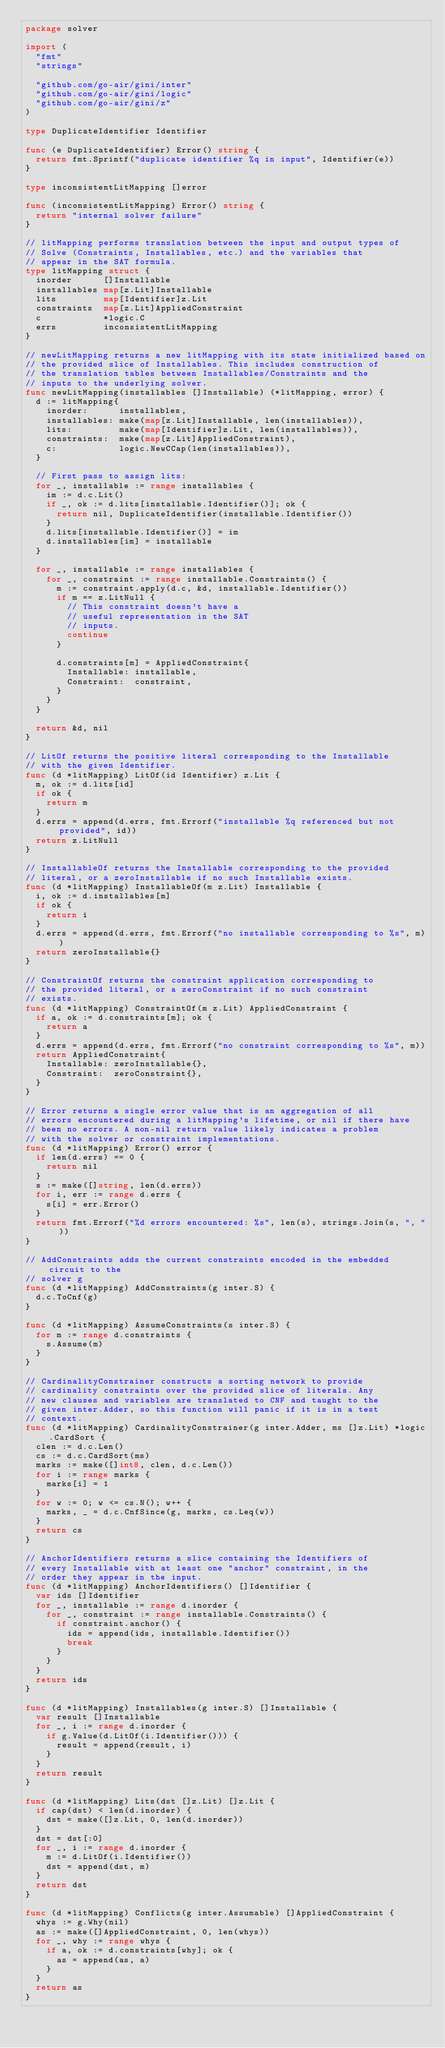<code> <loc_0><loc_0><loc_500><loc_500><_Go_>package solver

import (
	"fmt"
	"strings"

	"github.com/go-air/gini/inter"
	"github.com/go-air/gini/logic"
	"github.com/go-air/gini/z"
)

type DuplicateIdentifier Identifier

func (e DuplicateIdentifier) Error() string {
	return fmt.Sprintf("duplicate identifier %q in input", Identifier(e))
}

type inconsistentLitMapping []error

func (inconsistentLitMapping) Error() string {
	return "internal solver failure"
}

// litMapping performs translation between the input and output types of
// Solve (Constraints, Installables, etc.) and the variables that
// appear in the SAT formula.
type litMapping struct {
	inorder      []Installable
	installables map[z.Lit]Installable
	lits         map[Identifier]z.Lit
	constraints  map[z.Lit]AppliedConstraint
	c            *logic.C
	errs         inconsistentLitMapping
}

// newLitMapping returns a new litMapping with its state initialized based on
// the provided slice of Installables. This includes construction of
// the translation tables between Installables/Constraints and the
// inputs to the underlying solver.
func newLitMapping(installables []Installable) (*litMapping, error) {
	d := litMapping{
		inorder:      installables,
		installables: make(map[z.Lit]Installable, len(installables)),
		lits:         make(map[Identifier]z.Lit, len(installables)),
		constraints:  make(map[z.Lit]AppliedConstraint),
		c:            logic.NewCCap(len(installables)),
	}

	// First pass to assign lits:
	for _, installable := range installables {
		im := d.c.Lit()
		if _, ok := d.lits[installable.Identifier()]; ok {
			return nil, DuplicateIdentifier(installable.Identifier())
		}
		d.lits[installable.Identifier()] = im
		d.installables[im] = installable
	}

	for _, installable := range installables {
		for _, constraint := range installable.Constraints() {
			m := constraint.apply(d.c, &d, installable.Identifier())
			if m == z.LitNull {
				// This constraint doesn't have a
				// useful representation in the SAT
				// inputs.
				continue
			}

			d.constraints[m] = AppliedConstraint{
				Installable: installable,
				Constraint:  constraint,
			}
		}
	}

	return &d, nil
}

// LitOf returns the positive literal corresponding to the Installable
// with the given Identifier.
func (d *litMapping) LitOf(id Identifier) z.Lit {
	m, ok := d.lits[id]
	if ok {
		return m
	}
	d.errs = append(d.errs, fmt.Errorf("installable %q referenced but not provided", id))
	return z.LitNull
}

// InstallableOf returns the Installable corresponding to the provided
// literal, or a zeroInstallable if no such Installable exists.
func (d *litMapping) InstallableOf(m z.Lit) Installable {
	i, ok := d.installables[m]
	if ok {
		return i
	}
	d.errs = append(d.errs, fmt.Errorf("no installable corresponding to %s", m))
	return zeroInstallable{}
}

// ConstraintOf returns the constraint application corresponding to
// the provided literal, or a zeroConstraint if no such constraint
// exists.
func (d *litMapping) ConstraintOf(m z.Lit) AppliedConstraint {
	if a, ok := d.constraints[m]; ok {
		return a
	}
	d.errs = append(d.errs, fmt.Errorf("no constraint corresponding to %s", m))
	return AppliedConstraint{
		Installable: zeroInstallable{},
		Constraint:  zeroConstraint{},
	}
}

// Error returns a single error value that is an aggregation of all
// errors encountered during a litMapping's lifetime, or nil if there have
// been no errors. A non-nil return value likely indicates a problem
// with the solver or constraint implementations.
func (d *litMapping) Error() error {
	if len(d.errs) == 0 {
		return nil
	}
	s := make([]string, len(d.errs))
	for i, err := range d.errs {
		s[i] = err.Error()
	}
	return fmt.Errorf("%d errors encountered: %s", len(s), strings.Join(s, ", "))
}

// AddConstraints adds the current constraints encoded in the embedded circuit to the
// solver g
func (d *litMapping) AddConstraints(g inter.S) {
	d.c.ToCnf(g)
}

func (d *litMapping) AssumeConstraints(s inter.S) {
	for m := range d.constraints {
		s.Assume(m)
	}
}

// CardinalityConstrainer constructs a sorting network to provide
// cardinality constraints over the provided slice of literals. Any
// new clauses and variables are translated to CNF and taught to the
// given inter.Adder, so this function will panic if it is in a test
// context.
func (d *litMapping) CardinalityConstrainer(g inter.Adder, ms []z.Lit) *logic.CardSort {
	clen := d.c.Len()
	cs := d.c.CardSort(ms)
	marks := make([]int8, clen, d.c.Len())
	for i := range marks {
		marks[i] = 1
	}
	for w := 0; w <= cs.N(); w++ {
		marks, _ = d.c.CnfSince(g, marks, cs.Leq(w))
	}
	return cs
}

// AnchorIdentifiers returns a slice containing the Identifiers of
// every Installable with at least one "anchor" constraint, in the
// order they appear in the input.
func (d *litMapping) AnchorIdentifiers() []Identifier {
	var ids []Identifier
	for _, installable := range d.inorder {
		for _, constraint := range installable.Constraints() {
			if constraint.anchor() {
				ids = append(ids, installable.Identifier())
				break
			}
		}
	}
	return ids
}

func (d *litMapping) Installables(g inter.S) []Installable {
	var result []Installable
	for _, i := range d.inorder {
		if g.Value(d.LitOf(i.Identifier())) {
			result = append(result, i)
		}
	}
	return result
}

func (d *litMapping) Lits(dst []z.Lit) []z.Lit {
	if cap(dst) < len(d.inorder) {
		dst = make([]z.Lit, 0, len(d.inorder))
	}
	dst = dst[:0]
	for _, i := range d.inorder {
		m := d.LitOf(i.Identifier())
		dst = append(dst, m)
	}
	return dst
}

func (d *litMapping) Conflicts(g inter.Assumable) []AppliedConstraint {
	whys := g.Why(nil)
	as := make([]AppliedConstraint, 0, len(whys))
	for _, why := range whys {
		if a, ok := d.constraints[why]; ok {
			as = append(as, a)
		}
	}
	return as
}
</code> 